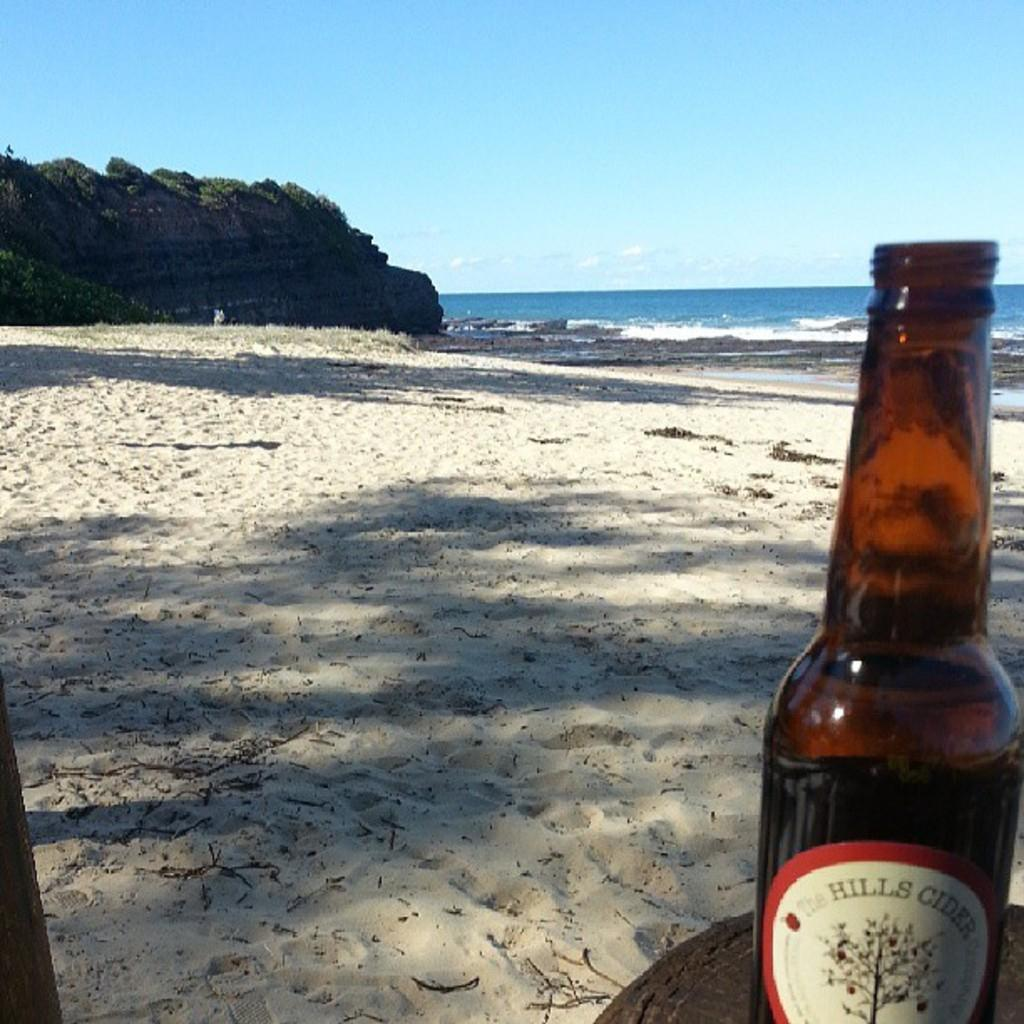<image>
Offer a succinct explanation of the picture presented. A bottle of Hills cider is on a beach in the shade. 